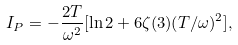Convert formula to latex. <formula><loc_0><loc_0><loc_500><loc_500>I _ { P } = - \frac { 2 T } { \omega ^ { 2 } } [ \ln 2 + 6 \zeta ( 3 ) ( T / \omega ) ^ { 2 } ] ,</formula> 